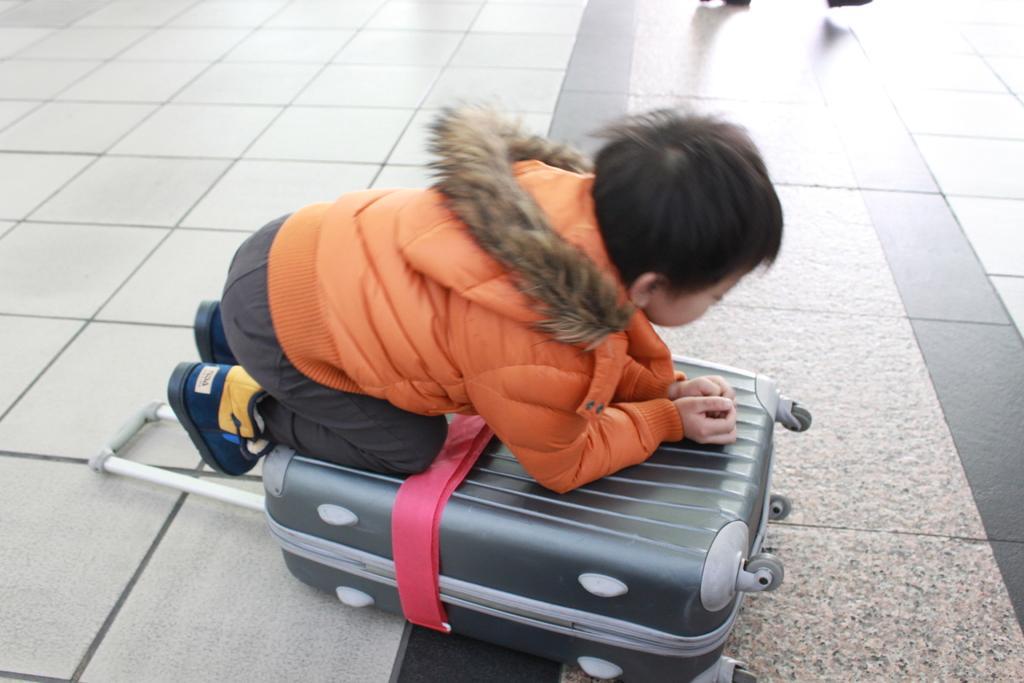Can you describe this image briefly? This is a floor where we can see a boy on a luggage bag wearing an orange colour jacket. 